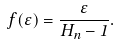Convert formula to latex. <formula><loc_0><loc_0><loc_500><loc_500>f ( \varepsilon ) = \frac { \varepsilon } { H _ { n } - 1 } .</formula> 